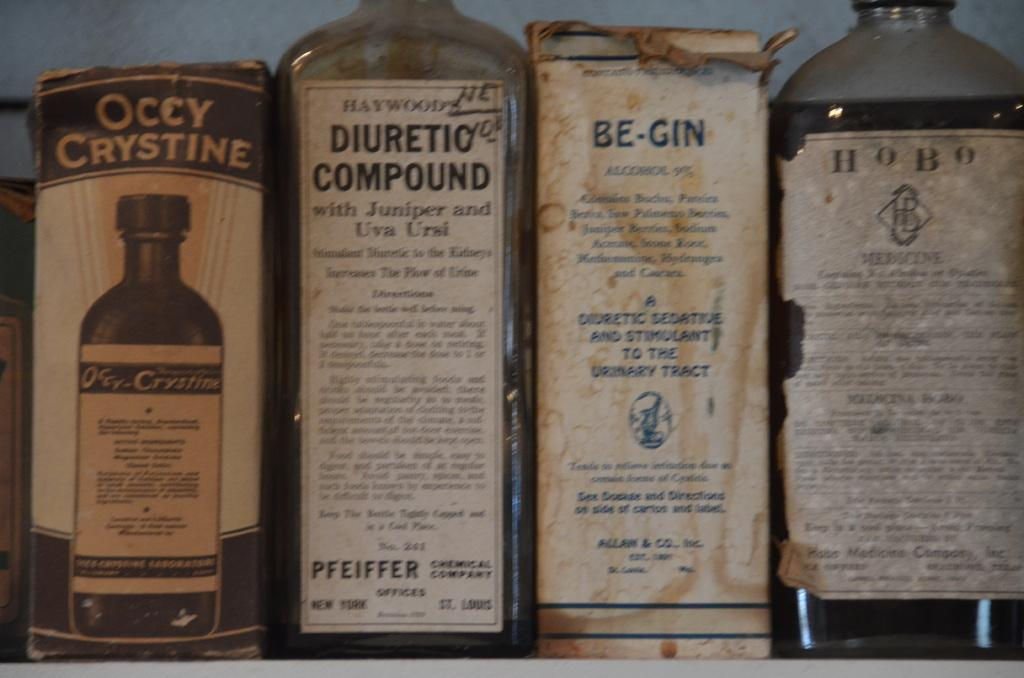<image>
Present a compact description of the photo's key features. An array of old bottles and boxes with the labels Occy Crystine, Diuretic Compound, Be-Gin, and Hobo on the packages. 